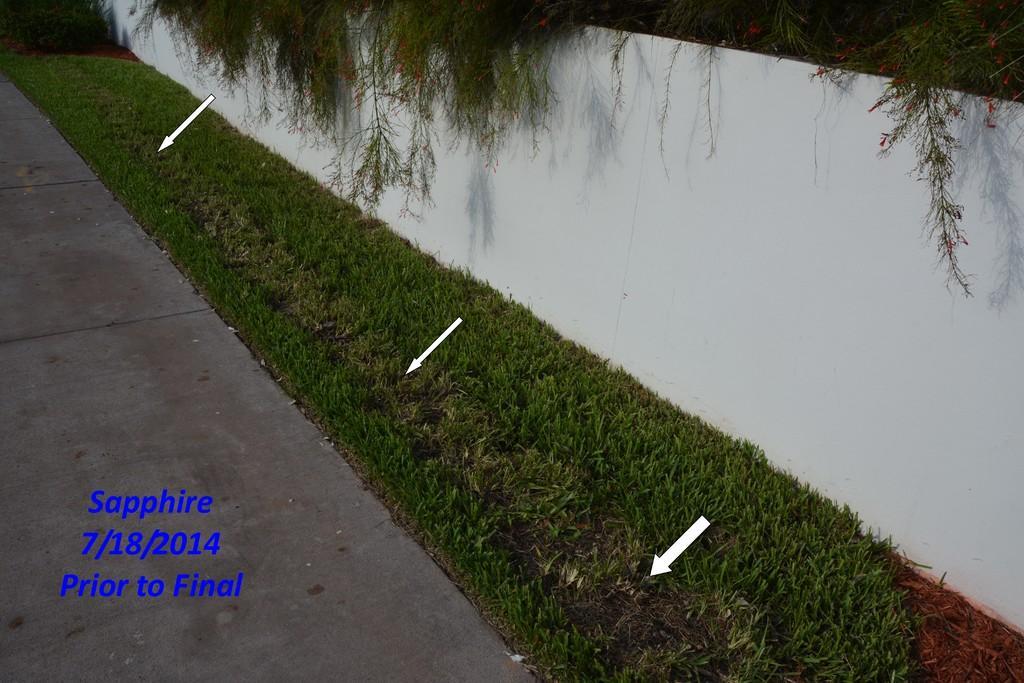Could you give a brief overview of what you see in this image? To the right side of the image there is wall. There is grass. In the center of the image there is road with some text on it. 